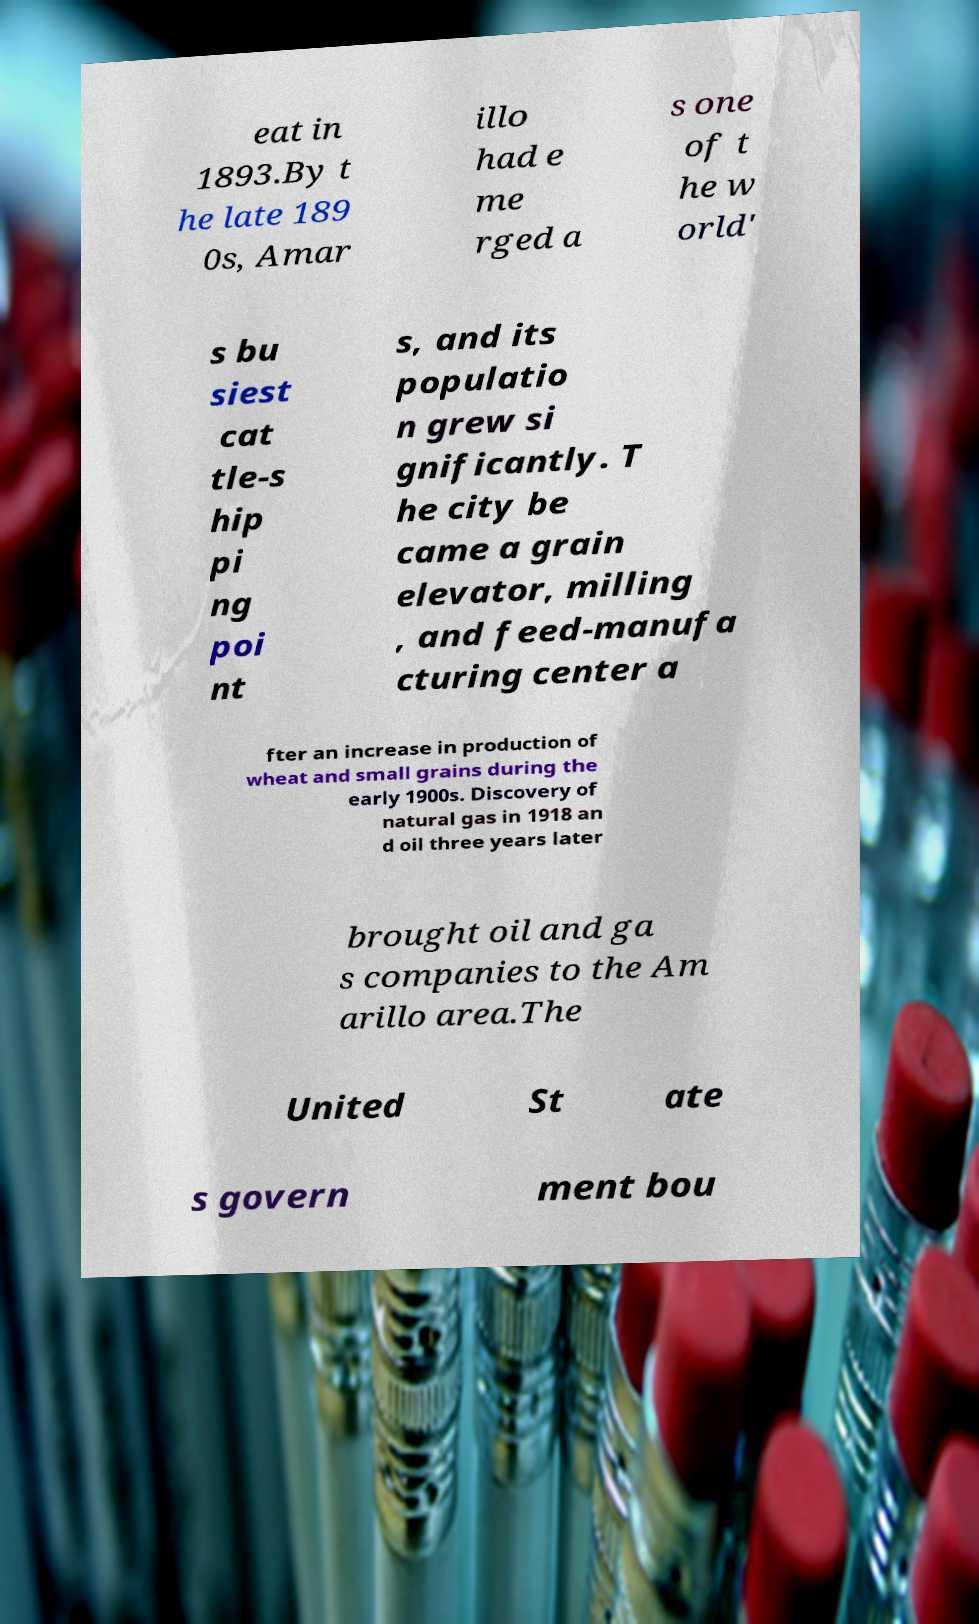Could you extract and type out the text from this image? eat in 1893.By t he late 189 0s, Amar illo had e me rged a s one of t he w orld' s bu siest cat tle-s hip pi ng poi nt s, and its populatio n grew si gnificantly. T he city be came a grain elevator, milling , and feed-manufa cturing center a fter an increase in production of wheat and small grains during the early 1900s. Discovery of natural gas in 1918 an d oil three years later brought oil and ga s companies to the Am arillo area.The United St ate s govern ment bou 